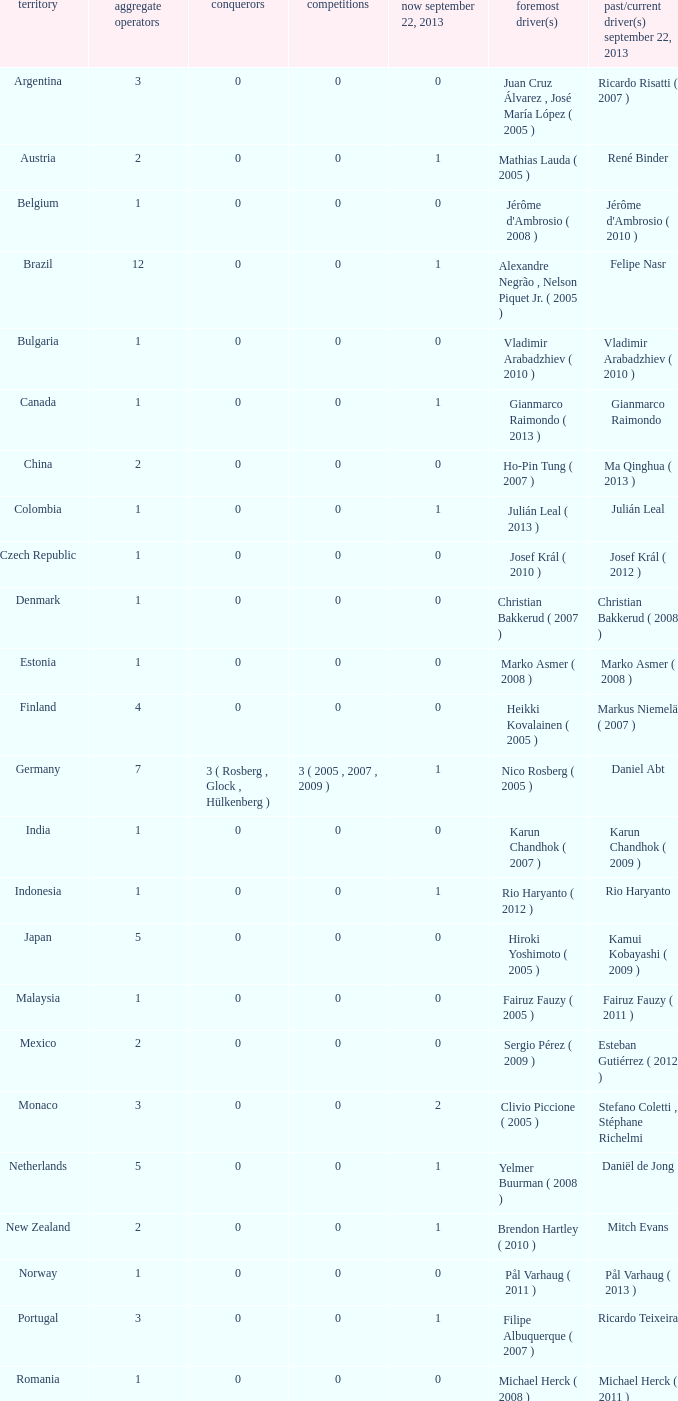How many entries are there for total drivers when the Last driver for september 22, 2013 was gianmarco raimondo? 1.0. 